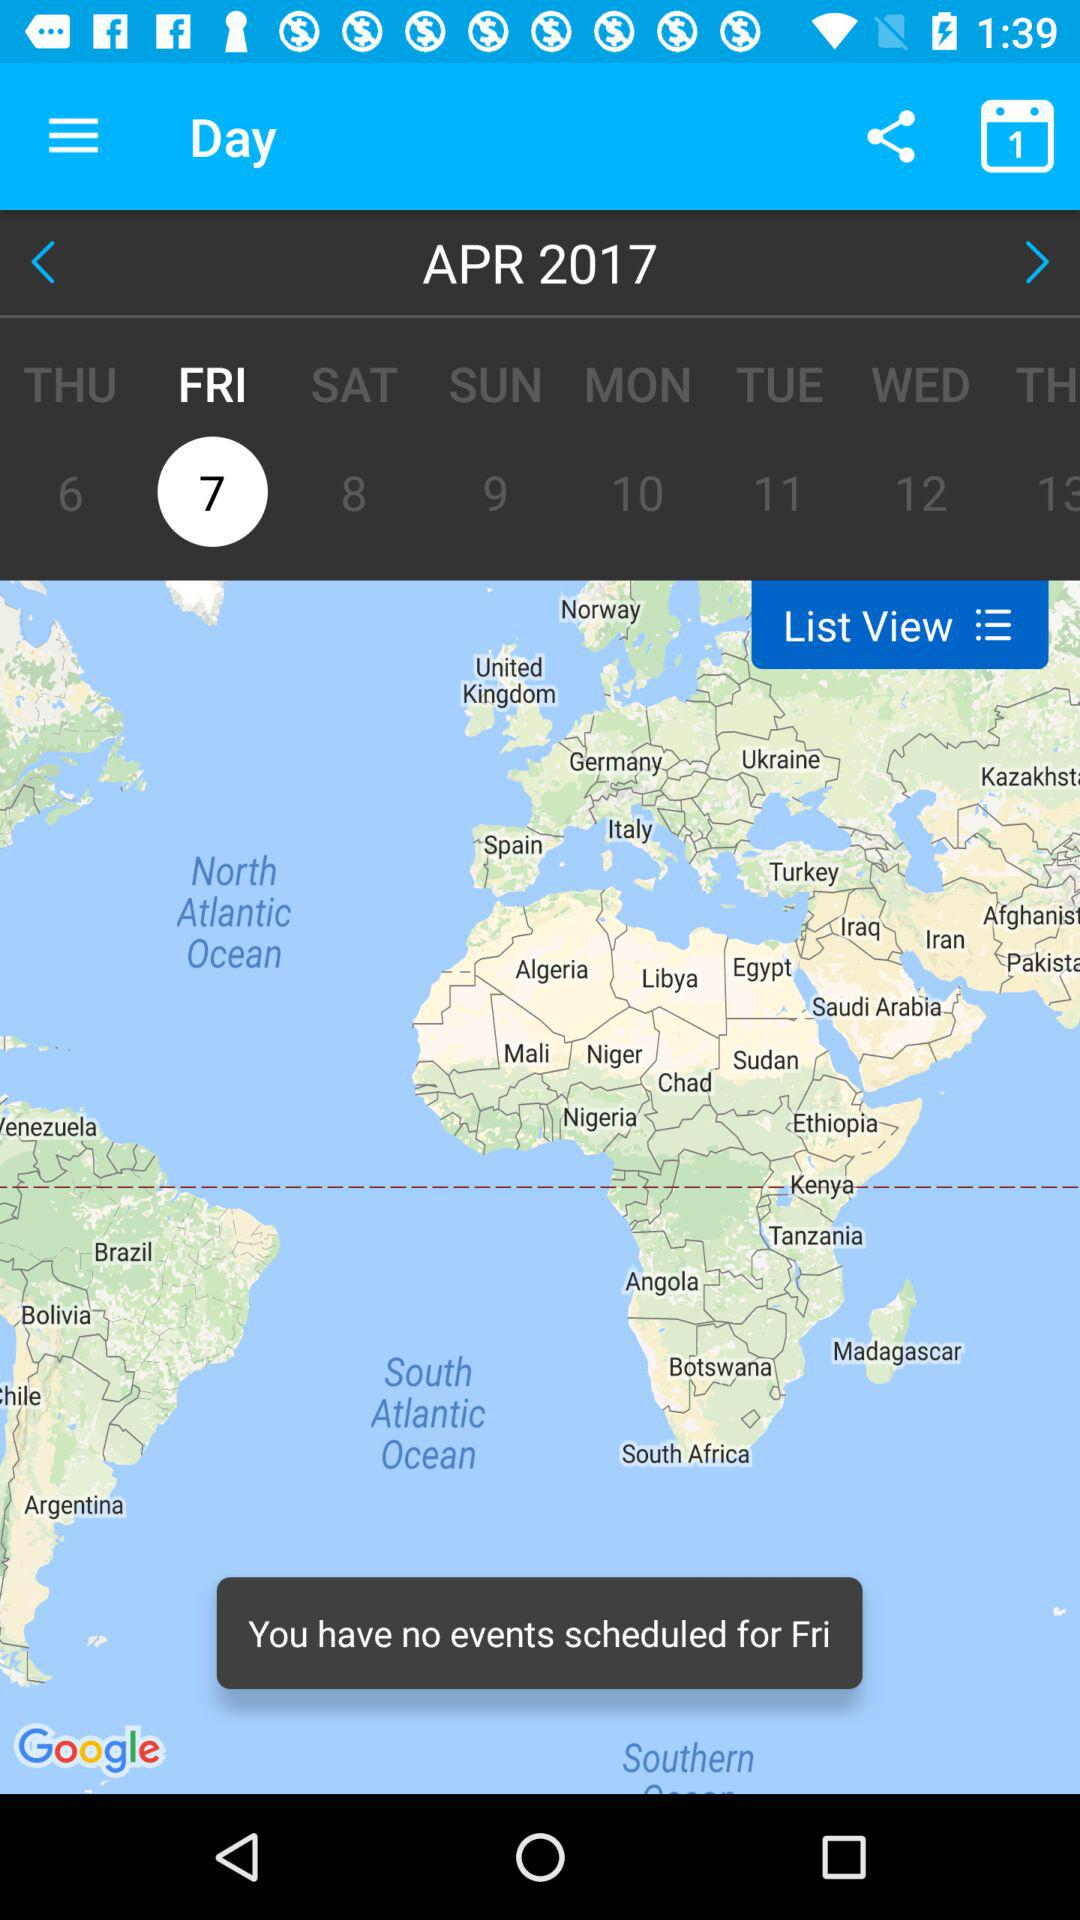What is the mentioned date on the calendar? The mentioned date on the calendar is Friday, April 7, 2017. 